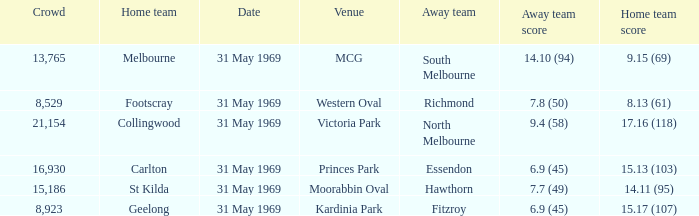In the contest with the home team's score of 15.17 (107), who were the away team players? Fitzroy. 